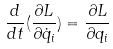<formula> <loc_0><loc_0><loc_500><loc_500>\frac { d } { d t } ( \frac { \partial L } { \partial \dot { q } _ { i } } ) = \frac { \partial L } { \partial q _ { i } }</formula> 